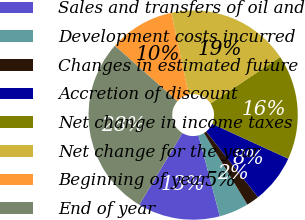Convert chart. <chart><loc_0><loc_0><loc_500><loc_500><pie_chart><fcel>Sales and transfers of oil and<fcel>Development costs incurred<fcel>Changes in estimated future<fcel>Accretion of discount<fcel>Net change in income taxes<fcel>Net change for the year<fcel>Beginning of year<fcel>End of year<nl><fcel>12.7%<fcel>4.57%<fcel>1.98%<fcel>7.51%<fcel>16.21%<fcel>18.98%<fcel>10.11%<fcel>27.94%<nl></chart> 